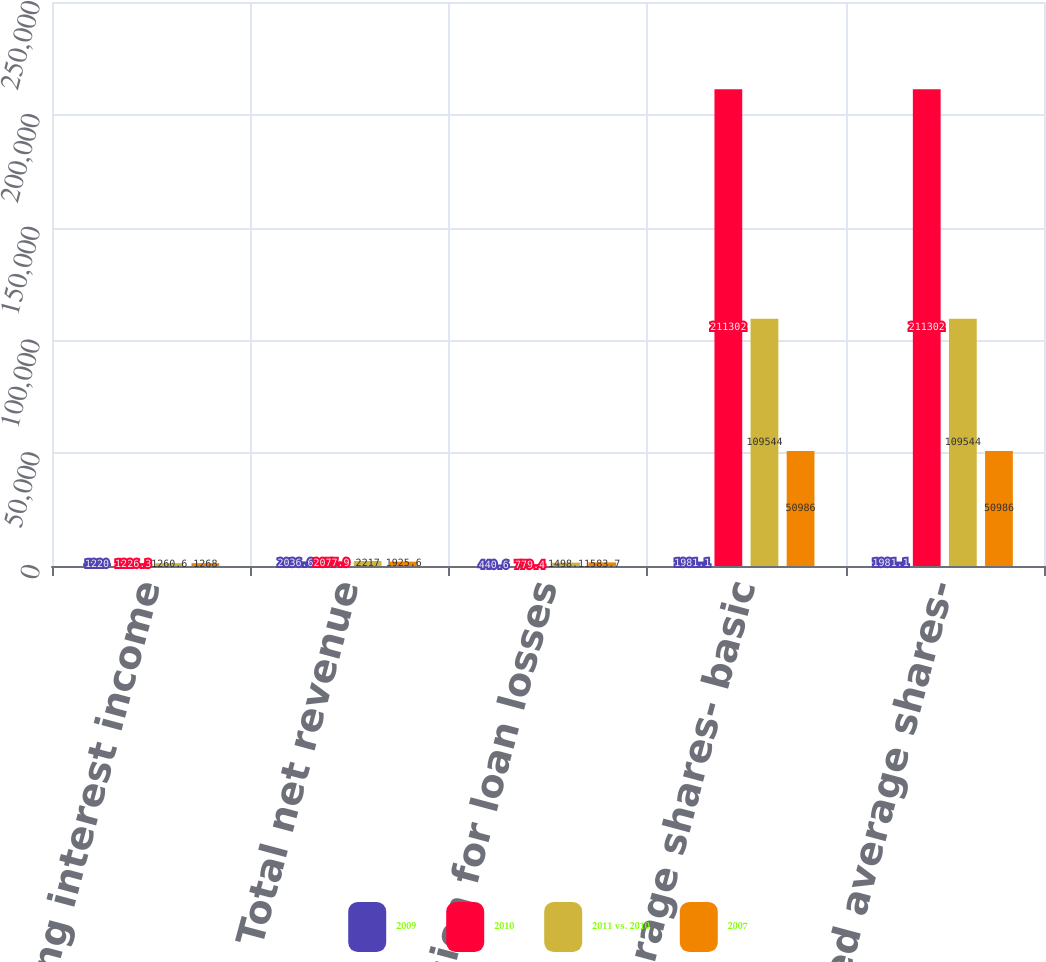<chart> <loc_0><loc_0><loc_500><loc_500><stacked_bar_chart><ecel><fcel>Net operating interest income<fcel>Total net revenue<fcel>Provision for loan losses<fcel>Weighted average shares- basic<fcel>Weighted average shares-<nl><fcel>2009<fcel>1220<fcel>2036.6<fcel>440.6<fcel>1981.1<fcel>1981.1<nl><fcel>2010<fcel>1226.3<fcel>2077.9<fcel>779.4<fcel>211302<fcel>211302<nl><fcel>2011 vs. 2010<fcel>1260.6<fcel>2217<fcel>1498.1<fcel>109544<fcel>109544<nl><fcel>2007<fcel>1268<fcel>1925.6<fcel>1583.7<fcel>50986<fcel>50986<nl></chart> 